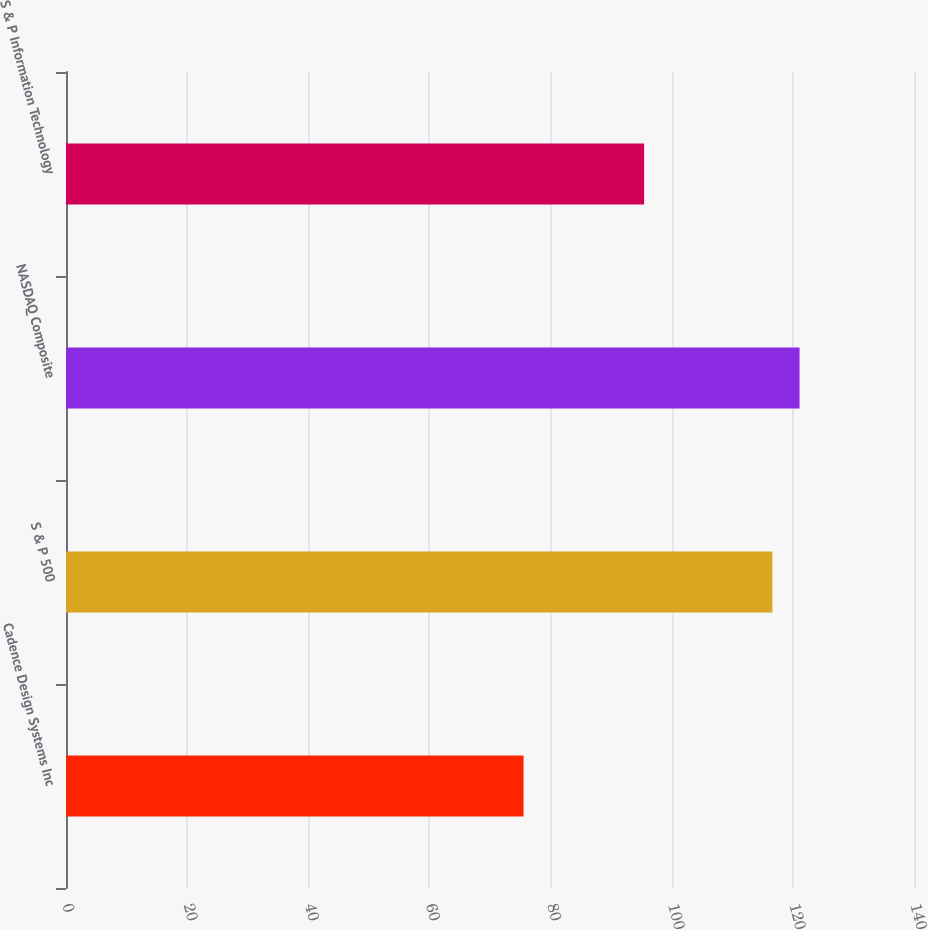Convert chart to OTSL. <chart><loc_0><loc_0><loc_500><loc_500><bar_chart><fcel>Cadence Design Systems Inc<fcel>S & P 500<fcel>NASDAQ Composite<fcel>S & P Information Technology<nl><fcel>75.54<fcel>116.61<fcel>121.11<fcel>95.44<nl></chart> 